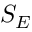<formula> <loc_0><loc_0><loc_500><loc_500>S _ { E }</formula> 